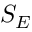<formula> <loc_0><loc_0><loc_500><loc_500>S _ { E }</formula> 